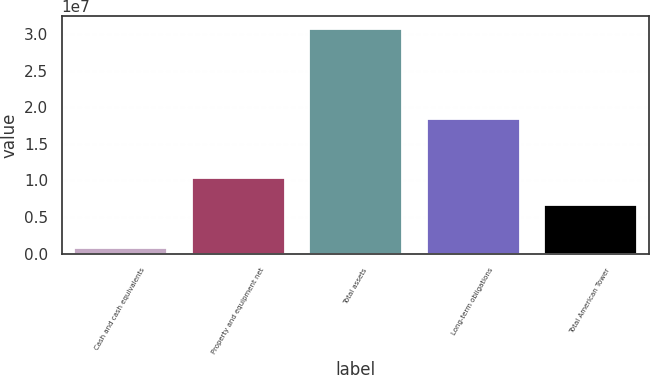<chart> <loc_0><loc_0><loc_500><loc_500><bar_chart><fcel>Cash and cash equivalents<fcel>Property and equipment net<fcel>Total assets<fcel>Long-term obligations<fcel>Total American Tower<nl><fcel>936442<fcel>1.05173e+07<fcel>3.08792e+07<fcel>1.85335e+07<fcel>6.7639e+06<nl></chart> 